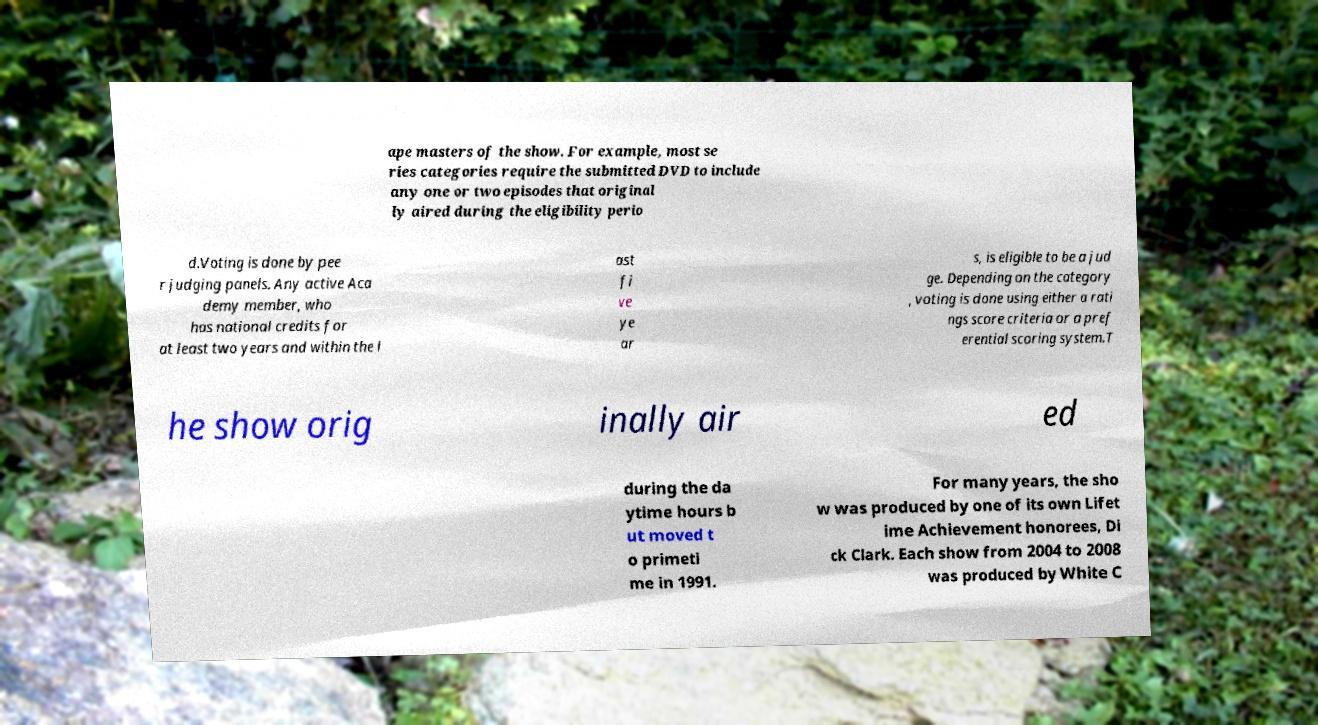Can you accurately transcribe the text from the provided image for me? ape masters of the show. For example, most se ries categories require the submitted DVD to include any one or two episodes that original ly aired during the eligibility perio d.Voting is done by pee r judging panels. Any active Aca demy member, who has national credits for at least two years and within the l ast fi ve ye ar s, is eligible to be a jud ge. Depending on the category , voting is done using either a rati ngs score criteria or a pref erential scoring system.T he show orig inally air ed during the da ytime hours b ut moved t o primeti me in 1991. For many years, the sho w was produced by one of its own Lifet ime Achievement honorees, Di ck Clark. Each show from 2004 to 2008 was produced by White C 